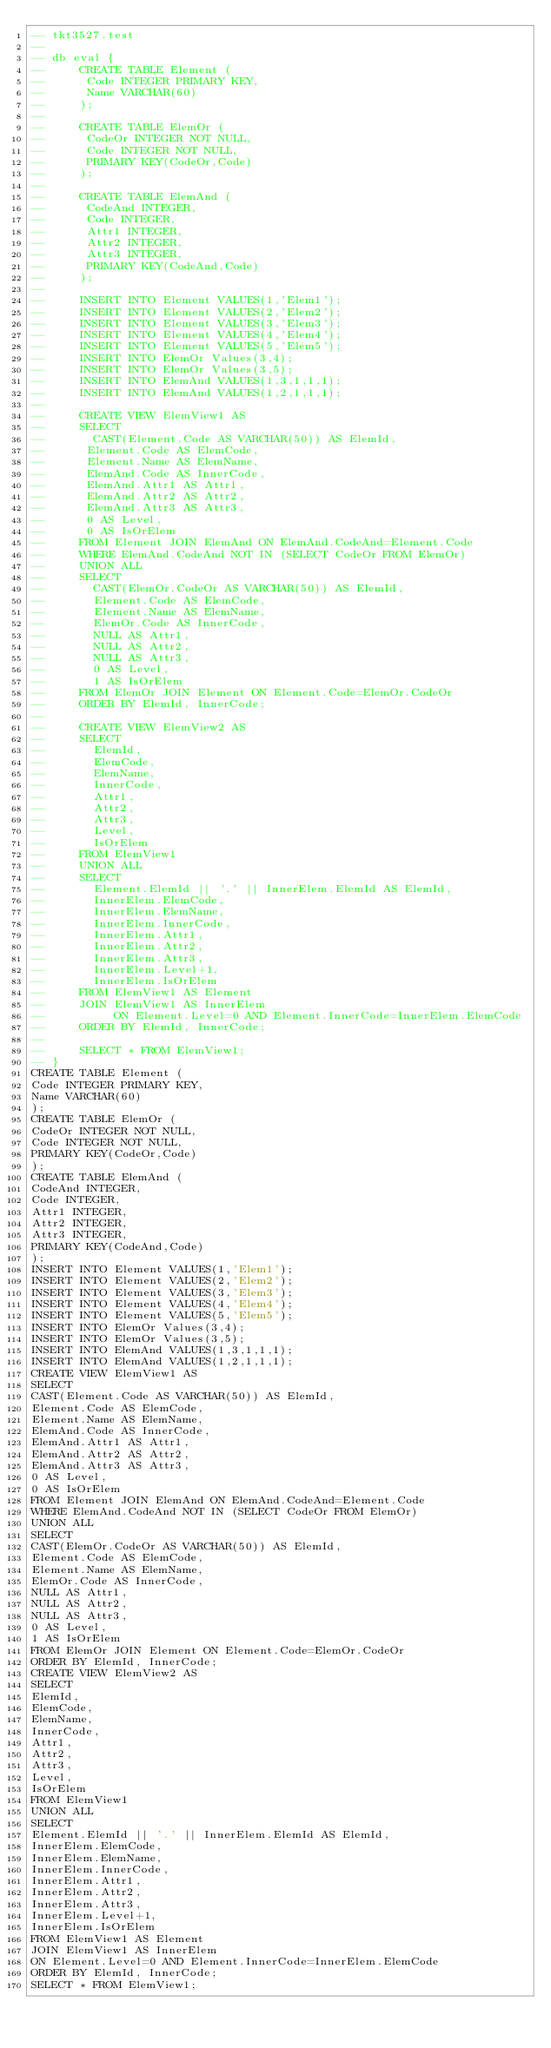Convert code to text. <code><loc_0><loc_0><loc_500><loc_500><_SQL_>-- tkt3527.test
-- 
-- db eval {
--     CREATE TABLE Element (
--      Code INTEGER PRIMARY KEY,
--      Name VARCHAR(60)
--     );
--     
--     CREATE TABLE ElemOr (
--      CodeOr INTEGER NOT NULL,
--      Code INTEGER NOT NULL,
--      PRIMARY KEY(CodeOr,Code)
--     );
--     
--     CREATE TABLE ElemAnd (
--      CodeAnd INTEGER,
--      Code INTEGER,
--      Attr1 INTEGER,
--      Attr2 INTEGER,
--      Attr3 INTEGER,
--      PRIMARY KEY(CodeAnd,Code)
--     );
--     
--     INSERT INTO Element VALUES(1,'Elem1');
--     INSERT INTO Element VALUES(2,'Elem2');
--     INSERT INTO Element VALUES(3,'Elem3');
--     INSERT INTO Element VALUES(4,'Elem4');
--     INSERT INTO Element VALUES(5,'Elem5');
--     INSERT INTO ElemOr Values(3,4);
--     INSERT INTO ElemOr Values(3,5);
--     INSERT INTO ElemAnd VALUES(1,3,1,1,1);
--     INSERT INTO ElemAnd VALUES(1,2,1,1,1);
--     
--     CREATE VIEW ElemView1 AS
--     SELECT
--       CAST(Element.Code AS VARCHAR(50)) AS ElemId,
--      Element.Code AS ElemCode,
--      Element.Name AS ElemName,
--      ElemAnd.Code AS InnerCode,
--      ElemAnd.Attr1 AS Attr1,
--      ElemAnd.Attr2 AS Attr2,
--      ElemAnd.Attr3 AS Attr3,
--      0 AS Level,
--      0 AS IsOrElem
--     FROM Element JOIN ElemAnd ON ElemAnd.CodeAnd=Element.Code
--     WHERE ElemAnd.CodeAnd NOT IN (SELECT CodeOr FROM ElemOr)
--     UNION ALL
--     SELECT
--       CAST(ElemOr.CodeOr AS VARCHAR(50)) AS ElemId,
--       Element.Code AS ElemCode,
--       Element.Name AS ElemName,
--       ElemOr.Code AS InnerCode,
--       NULL AS Attr1,
--       NULL AS Attr2,
--       NULL AS Attr3,
--       0 AS Level,
--       1 AS IsOrElem
--     FROM ElemOr JOIN Element ON Element.Code=ElemOr.CodeOr
--     ORDER BY ElemId, InnerCode;
--     
--     CREATE VIEW ElemView2 AS
--     SELECT
--       ElemId,
--       ElemCode,
--       ElemName,
--       InnerCode,
--       Attr1,
--       Attr2,
--       Attr3,
--       Level,
--       IsOrElem
--     FROM ElemView1
--     UNION ALL
--     SELECT
--       Element.ElemId || '.' || InnerElem.ElemId AS ElemId,
--       InnerElem.ElemCode,
--       InnerElem.ElemName,
--       InnerElem.InnerCode,
--       InnerElem.Attr1,
--       InnerElem.Attr2,
--       InnerElem.Attr3,
--       InnerElem.Level+1,
--       InnerElem.IsOrElem
--     FROM ElemView1 AS Element
--     JOIN ElemView1 AS InnerElem
--          ON Element.Level=0 AND Element.InnerCode=InnerElem.ElemCode
--     ORDER BY ElemId, InnerCode;
--  
--     SELECT * FROM ElemView1;
-- }
CREATE TABLE Element (
Code INTEGER PRIMARY KEY,
Name VARCHAR(60)
);
CREATE TABLE ElemOr (
CodeOr INTEGER NOT NULL,
Code INTEGER NOT NULL,
PRIMARY KEY(CodeOr,Code)
);
CREATE TABLE ElemAnd (
CodeAnd INTEGER,
Code INTEGER,
Attr1 INTEGER,
Attr2 INTEGER,
Attr3 INTEGER,
PRIMARY KEY(CodeAnd,Code)
);
INSERT INTO Element VALUES(1,'Elem1');
INSERT INTO Element VALUES(2,'Elem2');
INSERT INTO Element VALUES(3,'Elem3');
INSERT INTO Element VALUES(4,'Elem4');
INSERT INTO Element VALUES(5,'Elem5');
INSERT INTO ElemOr Values(3,4);
INSERT INTO ElemOr Values(3,5);
INSERT INTO ElemAnd VALUES(1,3,1,1,1);
INSERT INTO ElemAnd VALUES(1,2,1,1,1);
CREATE VIEW ElemView1 AS
SELECT
CAST(Element.Code AS VARCHAR(50)) AS ElemId,
Element.Code AS ElemCode,
Element.Name AS ElemName,
ElemAnd.Code AS InnerCode,
ElemAnd.Attr1 AS Attr1,
ElemAnd.Attr2 AS Attr2,
ElemAnd.Attr3 AS Attr3,
0 AS Level,
0 AS IsOrElem
FROM Element JOIN ElemAnd ON ElemAnd.CodeAnd=Element.Code
WHERE ElemAnd.CodeAnd NOT IN (SELECT CodeOr FROM ElemOr)
UNION ALL
SELECT
CAST(ElemOr.CodeOr AS VARCHAR(50)) AS ElemId,
Element.Code AS ElemCode,
Element.Name AS ElemName,
ElemOr.Code AS InnerCode,
NULL AS Attr1,
NULL AS Attr2,
NULL AS Attr3,
0 AS Level,
1 AS IsOrElem
FROM ElemOr JOIN Element ON Element.Code=ElemOr.CodeOr
ORDER BY ElemId, InnerCode;
CREATE VIEW ElemView2 AS
SELECT
ElemId,
ElemCode,
ElemName,
InnerCode,
Attr1,
Attr2,
Attr3,
Level,
IsOrElem
FROM ElemView1
UNION ALL
SELECT
Element.ElemId || '.' || InnerElem.ElemId AS ElemId,
InnerElem.ElemCode,
InnerElem.ElemName,
InnerElem.InnerCode,
InnerElem.Attr1,
InnerElem.Attr2,
InnerElem.Attr3,
InnerElem.Level+1,
InnerElem.IsOrElem
FROM ElemView1 AS Element
JOIN ElemView1 AS InnerElem
ON Element.Level=0 AND Element.InnerCode=InnerElem.ElemCode
ORDER BY ElemId, InnerCode;
SELECT * FROM ElemView1;</code> 